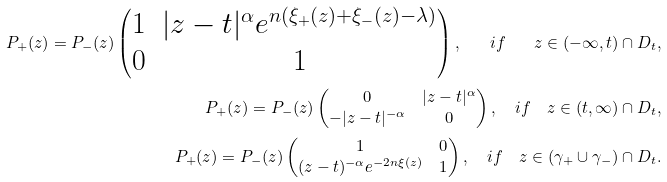Convert formula to latex. <formula><loc_0><loc_0><loc_500><loc_500>P _ { + } ( z ) = P _ { - } ( z ) \begin{pmatrix} 1 & | z - t | ^ { \alpha } e ^ { n ( \xi _ { + } ( z ) + \xi _ { - } ( z ) - \lambda ) } \\ 0 & 1 \end{pmatrix} , \quad i f \quad z \in ( - \infty , t ) \cap D _ { t } , \\ P _ { + } ( z ) = P _ { - } ( z ) \begin{pmatrix} 0 & | z - t | ^ { \alpha } \\ - | z - t | ^ { - \alpha } & 0 \end{pmatrix} , \quad i f \quad z \in ( t , \infty ) \cap D _ { t } , \\ P _ { + } ( z ) = P _ { - } ( z ) \begin{pmatrix} 1 & 0 \\ ( z - t ) ^ { - \alpha } e ^ { - 2 n \xi ( z ) } & 1 \end{pmatrix} , \quad i f \quad z \in ( \gamma _ { + } \cup \gamma _ { - } ) \cap D _ { t } .</formula> 